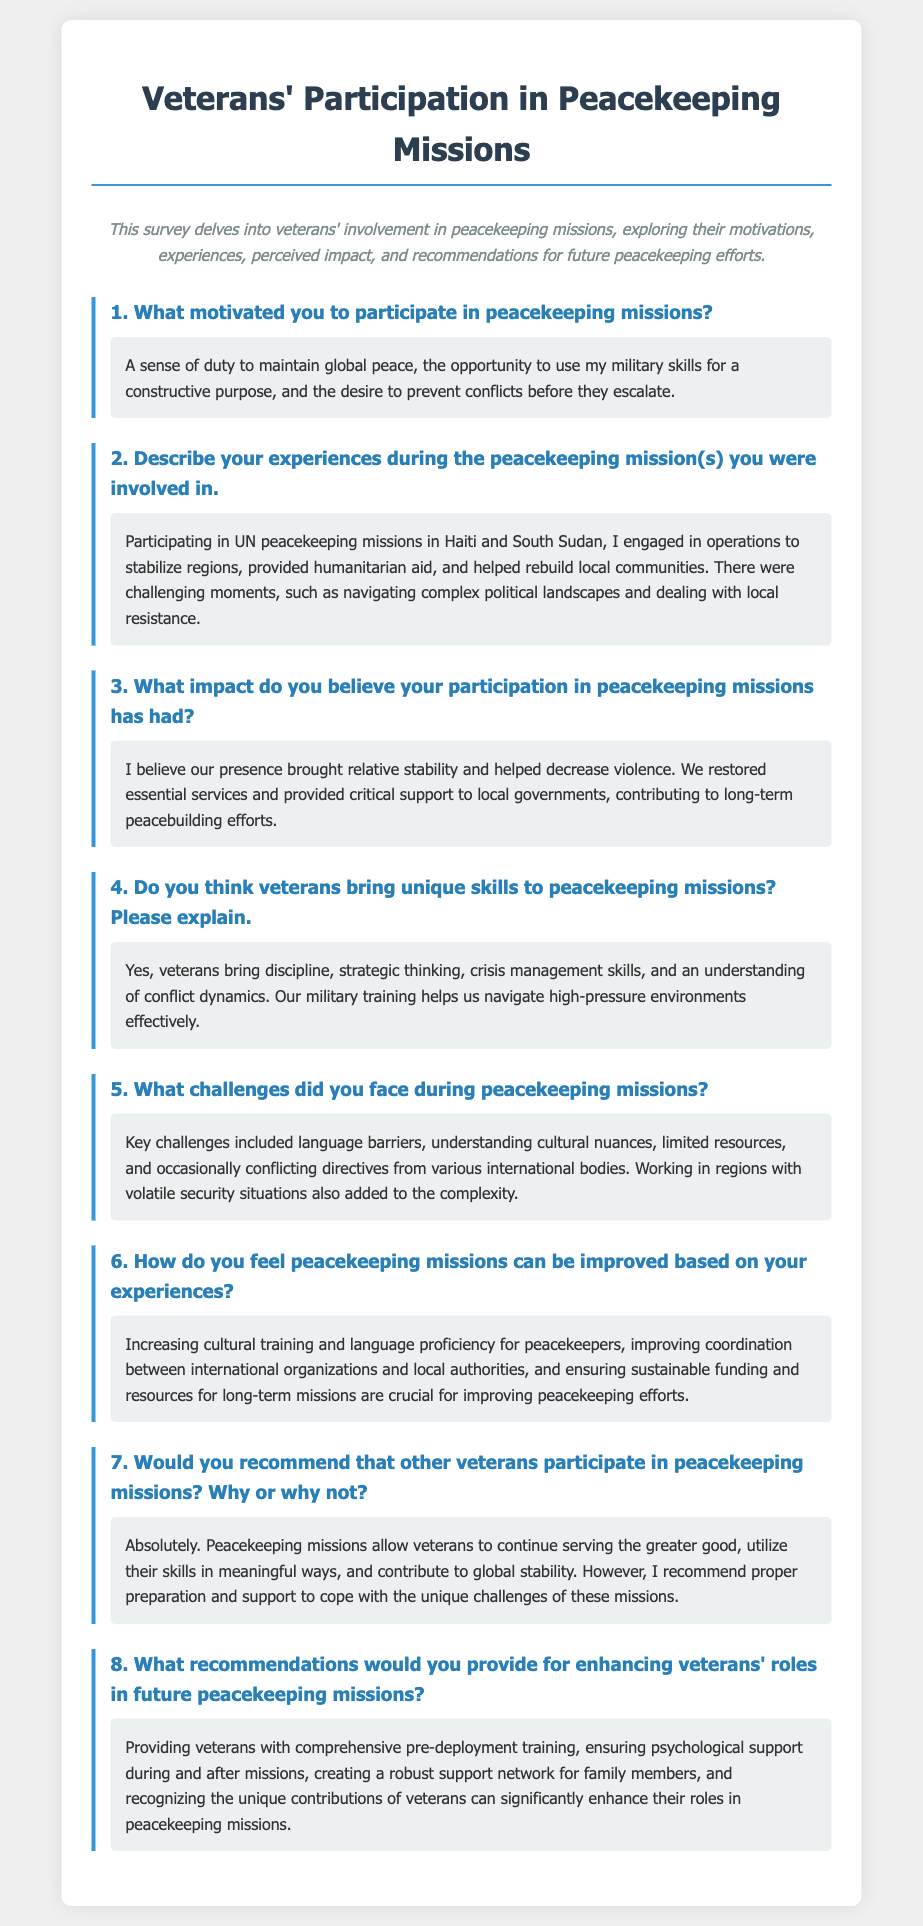What motivated the veteran to participate in peacekeeping missions? The motivation is stated in terms of a sense of duty, utilizing military skills constructively, and preventing conflicts.
Answer: A sense of duty to maintain global peace, the opportunity to use my military skills for a constructive purpose, and the desire to prevent conflicts before they escalate What regions did the veteran serve in during peacekeeping missions? The document specifically lists the locations of the veteran's missions as mentioned in their experiences.
Answer: Haiti and South Sudan What unique skills do veterans bring to peacekeeping missions? The answer highlights the specific skills attributed to veterans that aid in peacekeeping operations.
Answer: Discipline, strategic thinking, crisis management skills, and an understanding of conflict dynamics What challenges did the veteran face during missions? The challenges are enumerated in a concise list related to the experiences recounted.
Answer: Language barriers, understanding cultural nuances, limited resources, and occasionally conflicting directives How can peacekeeping missions be improved according to the veteran? The response includes several recommendations for enhancing future missions based on direct experience.
Answer: Increasing cultural training and language proficiency, improving coordination, and ensuring sustainable funding 